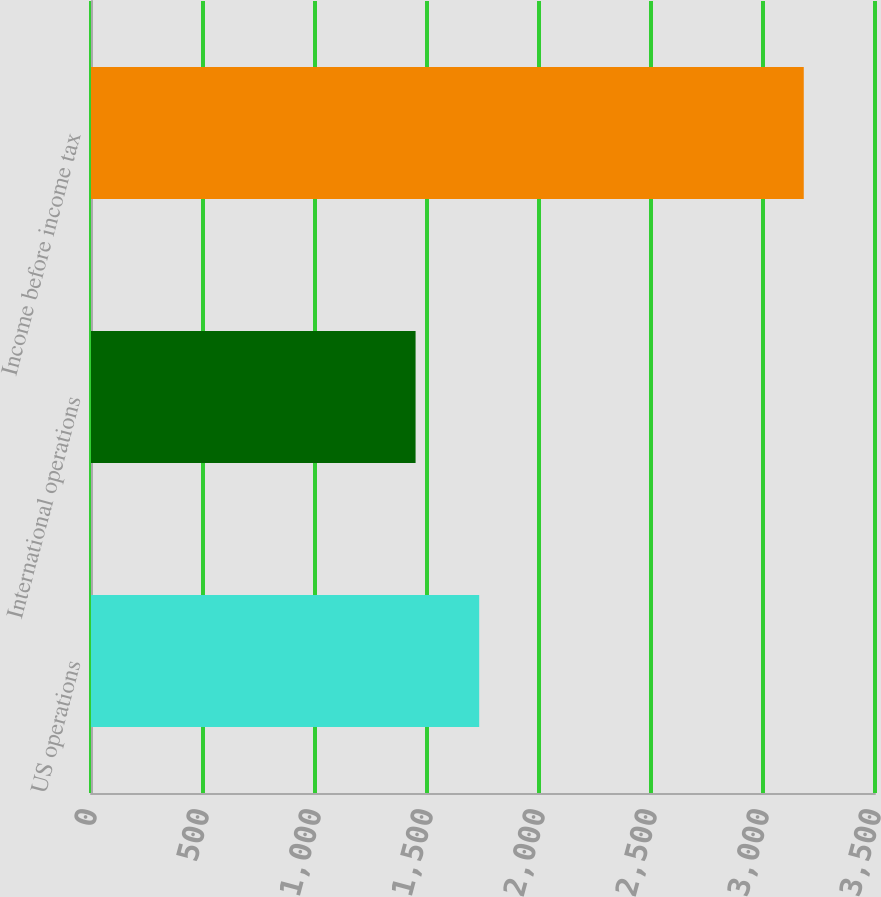Convert chart to OTSL. <chart><loc_0><loc_0><loc_500><loc_500><bar_chart><fcel>US operations<fcel>International operations<fcel>Income before income tax<nl><fcel>1733<fcel>1449<fcel>3182<nl></chart> 